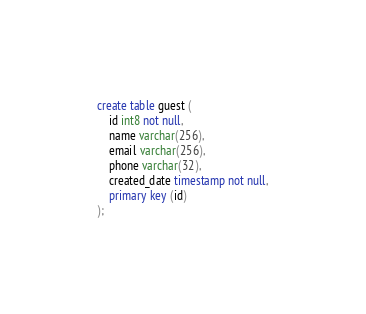Convert code to text. <code><loc_0><loc_0><loc_500><loc_500><_SQL_>create table guest (
    id int8 not null,
    name varchar(256),
    email varchar(256),
    phone varchar(32),
    created_date timestamp not null,
    primary key (id)
);
</code> 